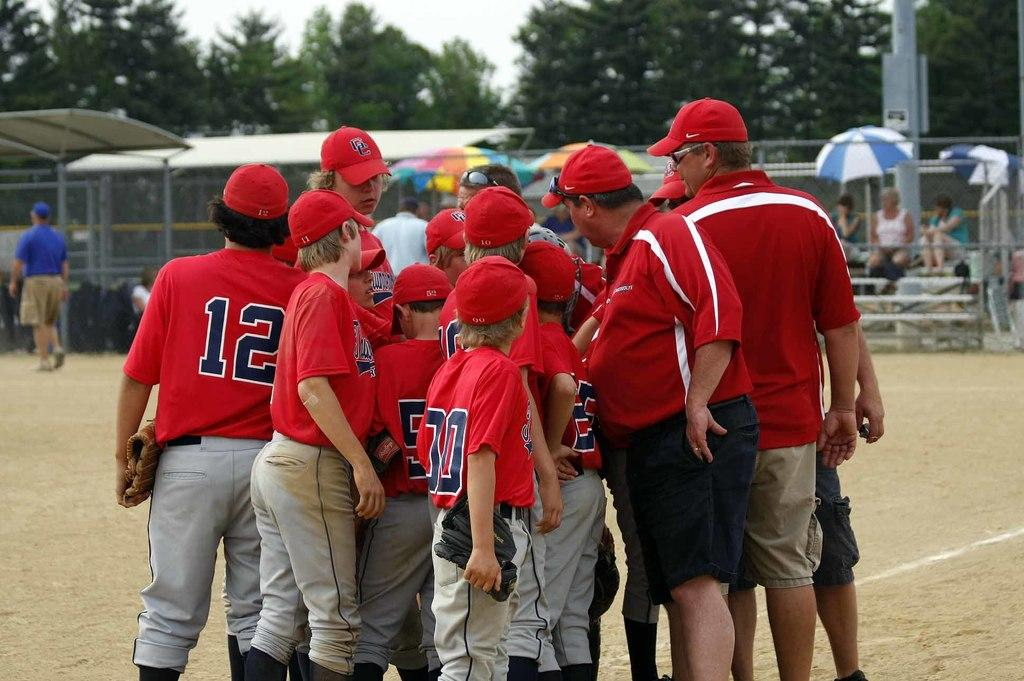<image>
Write a terse but informative summary of the picture. A baseball team of young boys with the letters CC on their caps are huddled together to the side of the field. 